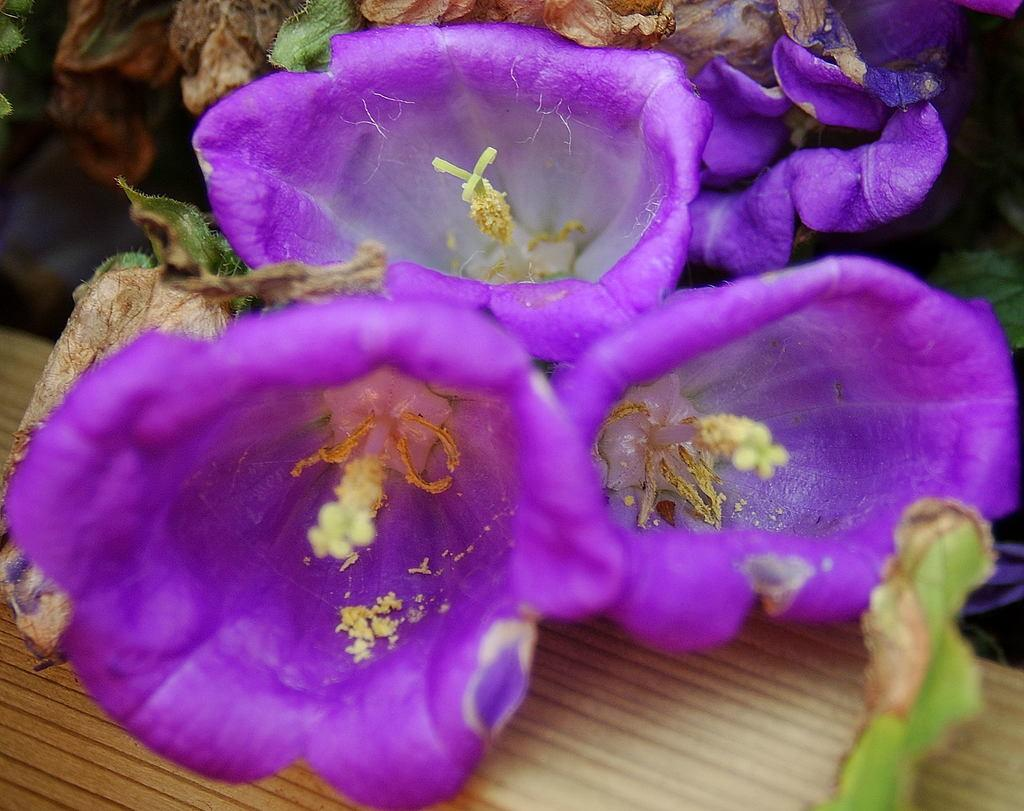What is the main object in the center of the image? There is a wooden object in the center of the image. What type of flora is present in the image? There are flowers in the image. What colors are the flowers? The flowers are in violet and white colors. What can be seen in the background of the image? There are planets and a few other objects visible in the background of the image. What type of leaf is visible on the ground in the image? There is no leaf or ground visible in the image; it features a wooden object, flowers, and a background with planets and other objects. 